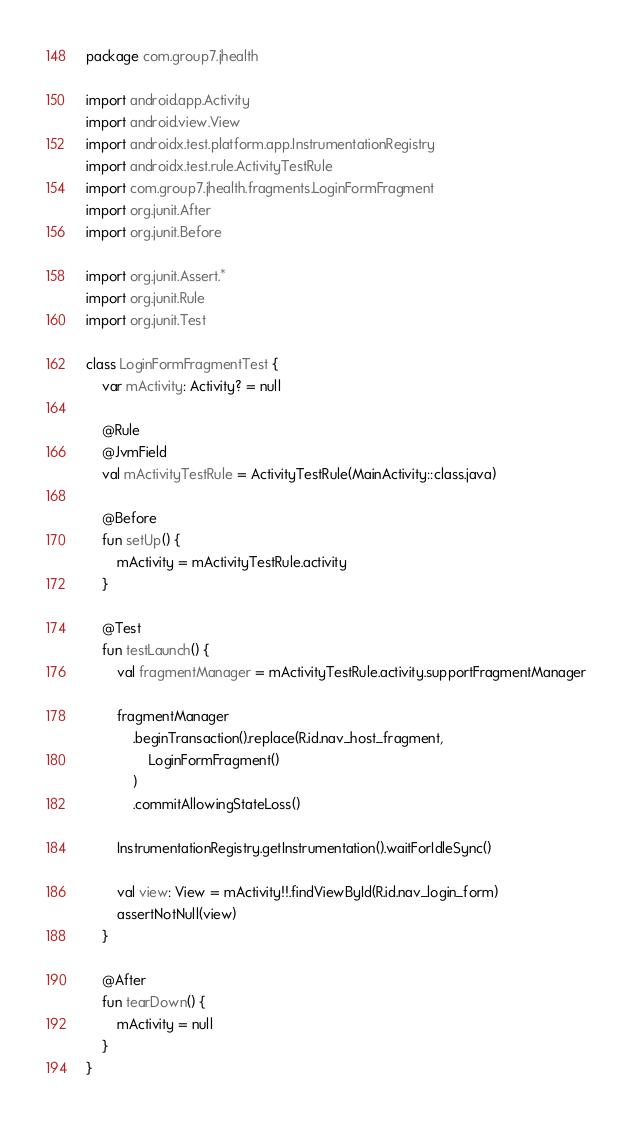Convert code to text. <code><loc_0><loc_0><loc_500><loc_500><_Kotlin_>package com.group7.jhealth

import android.app.Activity
import android.view.View
import androidx.test.platform.app.InstrumentationRegistry
import androidx.test.rule.ActivityTestRule
import com.group7.jhealth.fragments.LoginFormFragment
import org.junit.After
import org.junit.Before

import org.junit.Assert.*
import org.junit.Rule
import org.junit.Test

class LoginFormFragmentTest {
    var mActivity: Activity? = null

    @Rule
    @JvmField
    val mActivityTestRule = ActivityTestRule(MainActivity::class.java)

    @Before
    fun setUp() {
        mActivity = mActivityTestRule.activity
    }

    @Test
    fun testLaunch() {
        val fragmentManager = mActivityTestRule.activity.supportFragmentManager

        fragmentManager
            .beginTransaction().replace(R.id.nav_host_fragment,
                LoginFormFragment()
            )
            .commitAllowingStateLoss()

        InstrumentationRegistry.getInstrumentation().waitForIdleSync()

        val view: View = mActivity!!.findViewById(R.id.nav_login_form)
        assertNotNull(view)
    }

    @After
    fun tearDown() {
        mActivity = null
    }
}</code> 